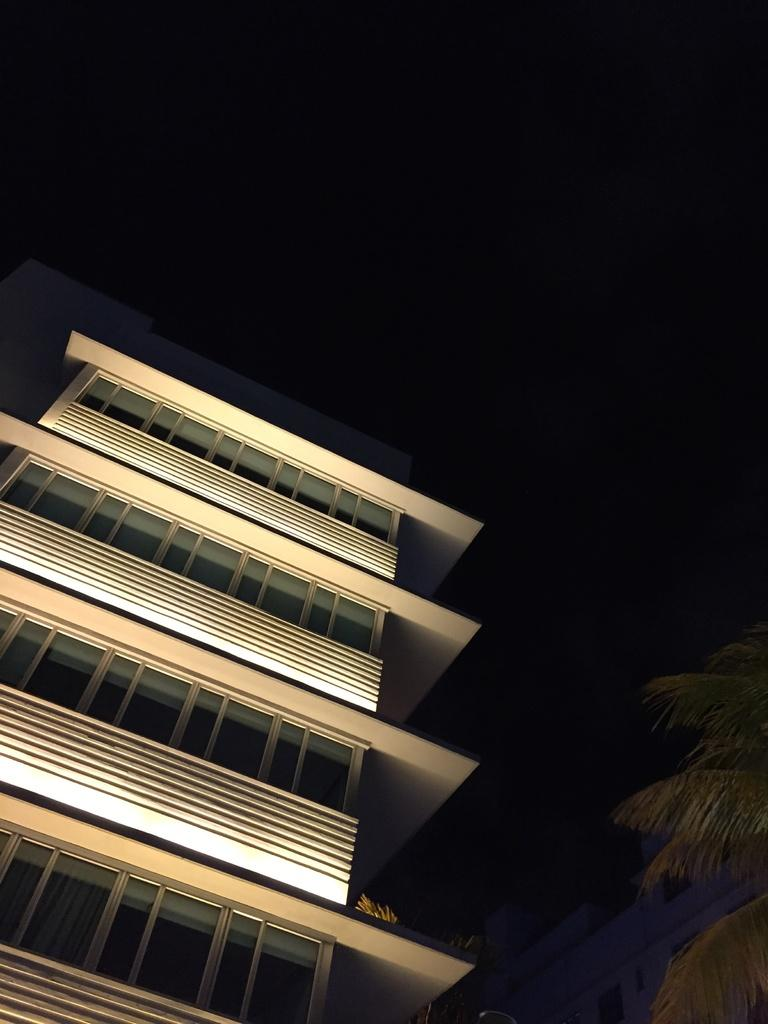What type of structure is visible in the image? There is a building with lights in the image. What can be seen on the right side of the image? There are trees on the right side of the image. How many buns are stacked on the books in the image? There are no buns or books present in the image. 